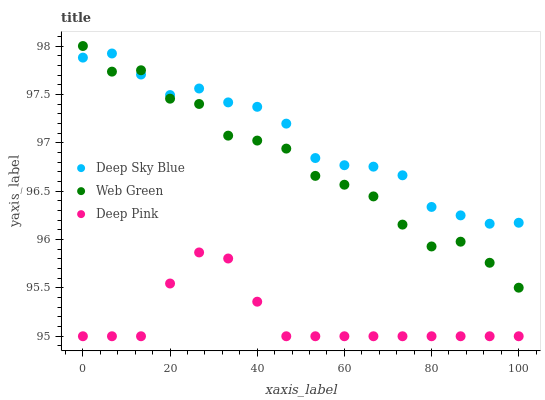Does Deep Pink have the minimum area under the curve?
Answer yes or no. Yes. Does Deep Sky Blue have the maximum area under the curve?
Answer yes or no. Yes. Does Web Green have the minimum area under the curve?
Answer yes or no. No. Does Web Green have the maximum area under the curve?
Answer yes or no. No. Is Deep Pink the smoothest?
Answer yes or no. Yes. Is Web Green the roughest?
Answer yes or no. Yes. Is Deep Sky Blue the smoothest?
Answer yes or no. No. Is Deep Sky Blue the roughest?
Answer yes or no. No. Does Deep Pink have the lowest value?
Answer yes or no. Yes. Does Web Green have the lowest value?
Answer yes or no. No. Does Web Green have the highest value?
Answer yes or no. Yes. Does Deep Sky Blue have the highest value?
Answer yes or no. No. Is Deep Pink less than Web Green?
Answer yes or no. Yes. Is Deep Sky Blue greater than Deep Pink?
Answer yes or no. Yes. Does Web Green intersect Deep Sky Blue?
Answer yes or no. Yes. Is Web Green less than Deep Sky Blue?
Answer yes or no. No. Is Web Green greater than Deep Sky Blue?
Answer yes or no. No. Does Deep Pink intersect Web Green?
Answer yes or no. No. 